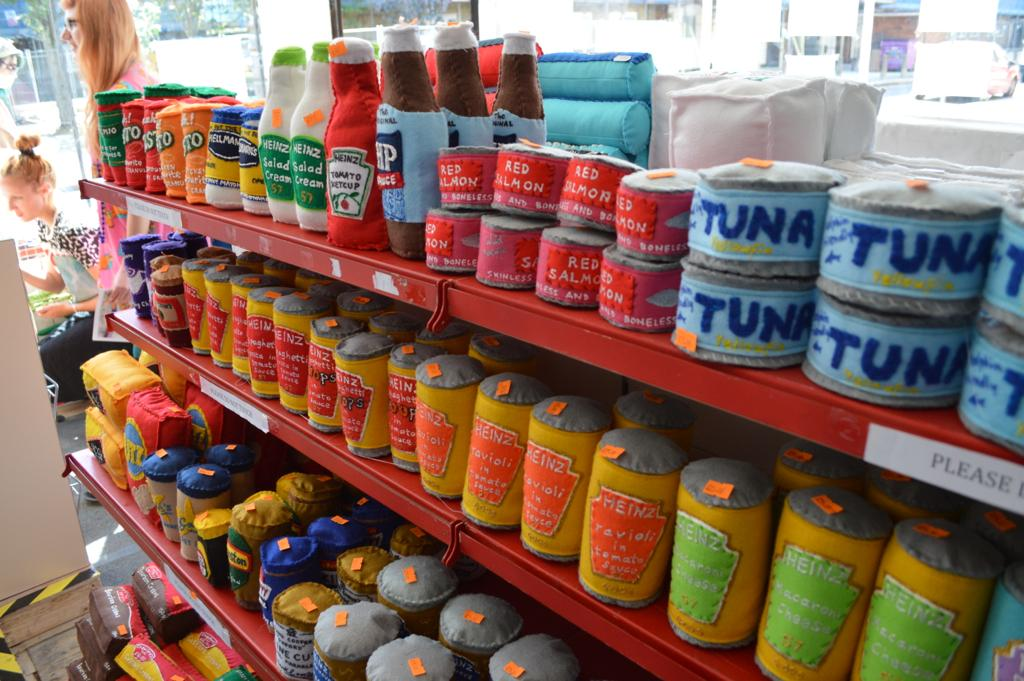Provide a one-sentence caption for the provided image. a shelf filled with stuffed toy food items on it including tuna. 